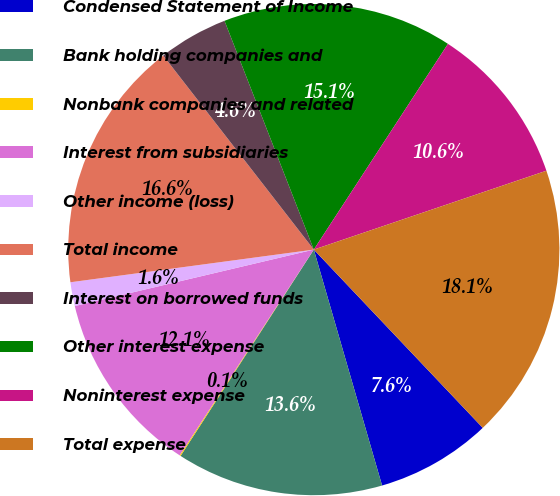Convert chart to OTSL. <chart><loc_0><loc_0><loc_500><loc_500><pie_chart><fcel>Condensed Statement of Income<fcel>Bank holding companies and<fcel>Nonbank companies and related<fcel>Interest from subsidiaries<fcel>Other income (loss)<fcel>Total income<fcel>Interest on borrowed funds<fcel>Other interest expense<fcel>Noninterest expense<fcel>Total expense<nl><fcel>7.59%<fcel>13.61%<fcel>0.07%<fcel>12.11%<fcel>1.57%<fcel>16.62%<fcel>4.58%<fcel>15.12%<fcel>10.6%<fcel>18.13%<nl></chart> 